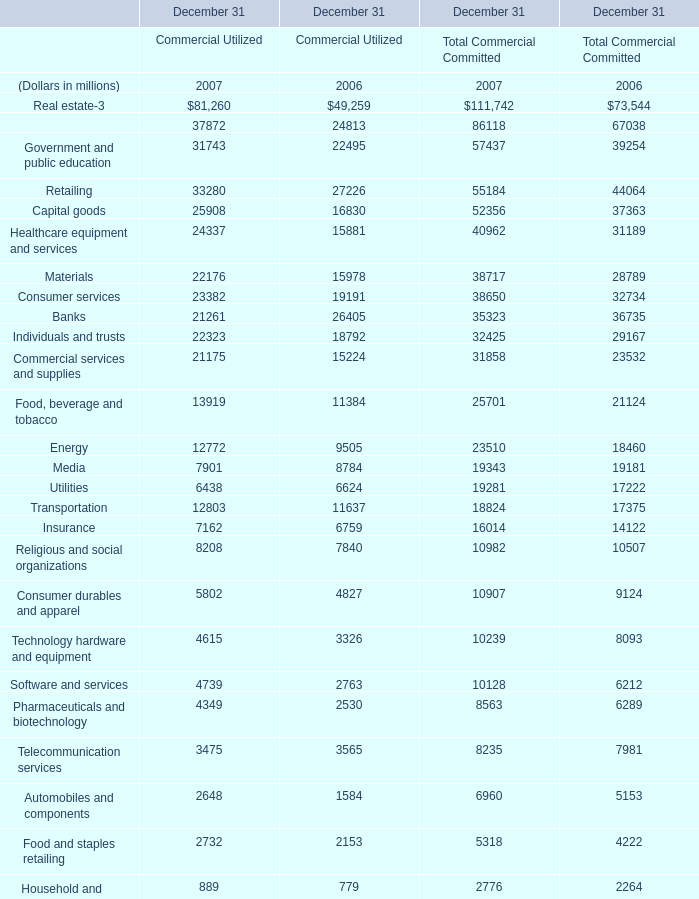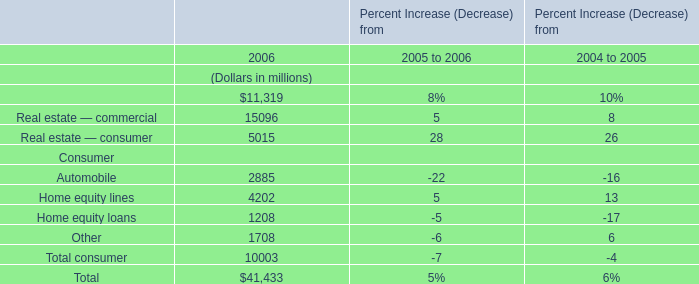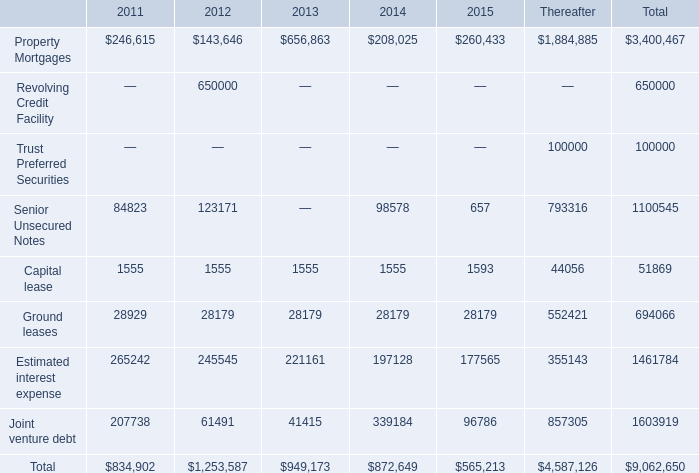what percentage of 2013 obligations was the 2013 capital lease obligation 
Computations: (1555 / 949173)
Answer: 0.00164. 